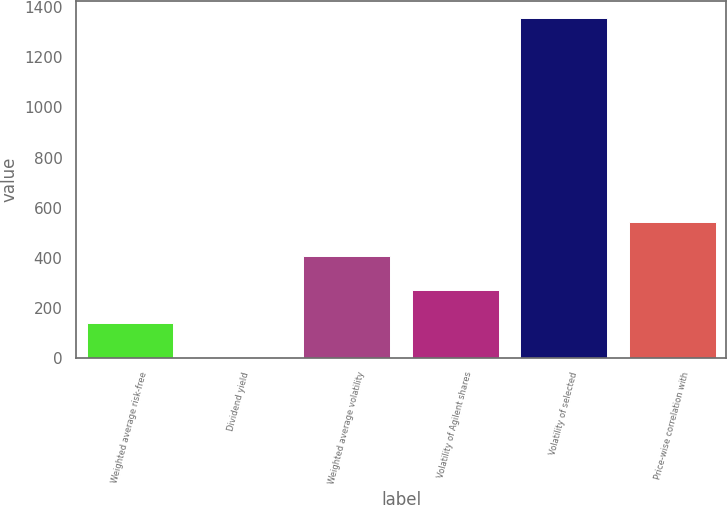Convert chart to OTSL. <chart><loc_0><loc_0><loc_500><loc_500><bar_chart><fcel>Weighted average risk-free<fcel>Dividend yield<fcel>Weighted average volatility<fcel>Volatility of Agilent shares<fcel>Volatility of selected<fcel>Price-wise correlation with<nl><fcel>136.6<fcel>1<fcel>407.8<fcel>272.2<fcel>1357<fcel>543.4<nl></chart> 